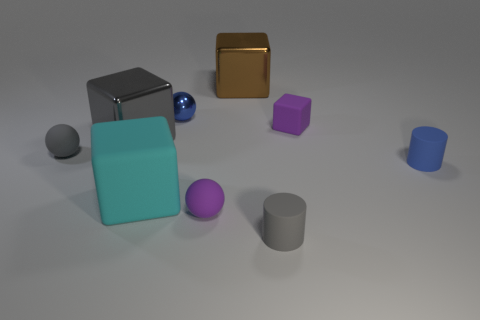Subtract 1 cubes. How many cubes are left? 3 Subtract all spheres. How many objects are left? 6 Add 2 tiny metallic balls. How many tiny metallic balls are left? 3 Add 8 big brown metallic blocks. How many big brown metallic blocks exist? 9 Subtract 0 yellow blocks. How many objects are left? 9 Subtract all large cyan spheres. Subtract all gray blocks. How many objects are left? 8 